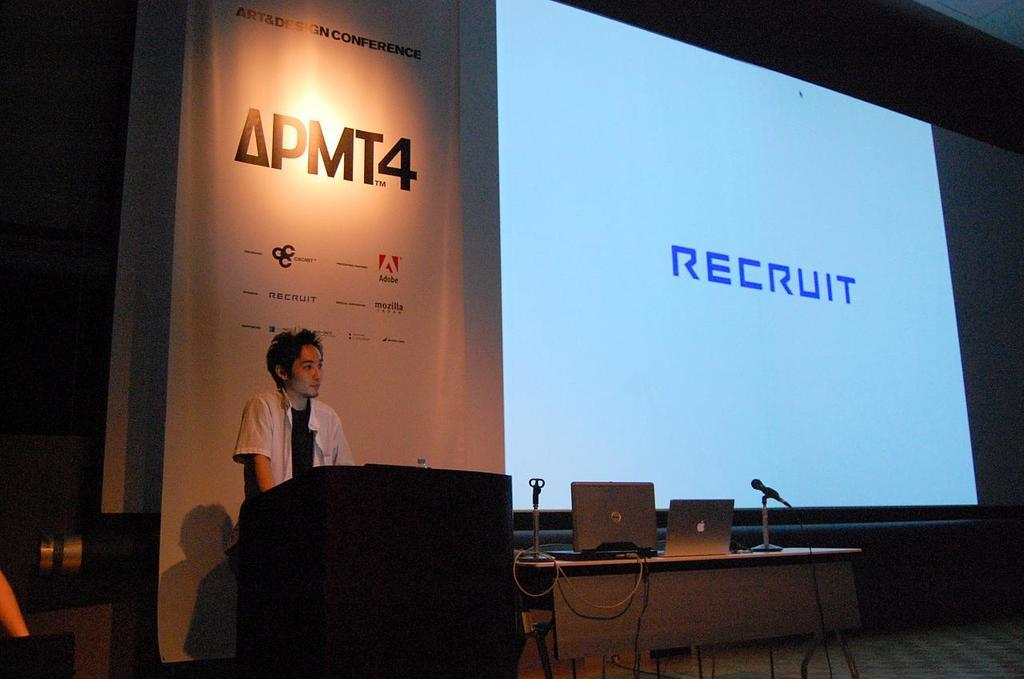Who is present in the image? There is a man in the image. What object can be seen in front of the man? There is a podium in the image. What is on the table in the image? There are laptops on the table. What device is used for amplifying sound in the image? There is a microphone in the image. What can be seen in the background of the image? There is a screen and a banner in the background of the image. What type of beef is being served at the event in the image? There is no mention of beef or any food in the image. The focus is on the man, podium, table, laptops, microphone, screen, and banner. 